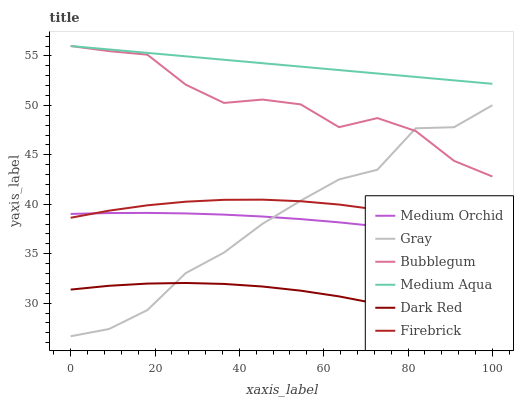Does Dark Red have the minimum area under the curve?
Answer yes or no. Yes. Does Medium Aqua have the maximum area under the curve?
Answer yes or no. Yes. Does Firebrick have the minimum area under the curve?
Answer yes or no. No. Does Firebrick have the maximum area under the curve?
Answer yes or no. No. Is Medium Aqua the smoothest?
Answer yes or no. Yes. Is Bubblegum the roughest?
Answer yes or no. Yes. Is Dark Red the smoothest?
Answer yes or no. No. Is Dark Red the roughest?
Answer yes or no. No. Does Gray have the lowest value?
Answer yes or no. Yes. Does Dark Red have the lowest value?
Answer yes or no. No. Does Medium Aqua have the highest value?
Answer yes or no. Yes. Does Firebrick have the highest value?
Answer yes or no. No. Is Firebrick less than Bubblegum?
Answer yes or no. Yes. Is Medium Aqua greater than Dark Red?
Answer yes or no. Yes. Does Gray intersect Bubblegum?
Answer yes or no. Yes. Is Gray less than Bubblegum?
Answer yes or no. No. Is Gray greater than Bubblegum?
Answer yes or no. No. Does Firebrick intersect Bubblegum?
Answer yes or no. No. 